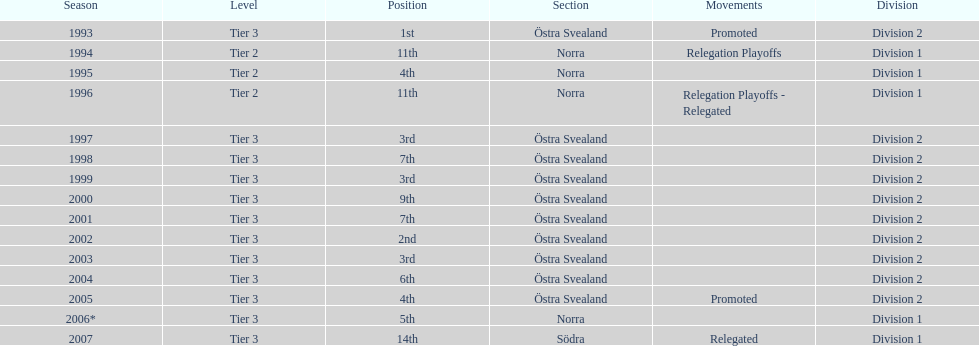What section did they play in the most? Östra Svealand. 